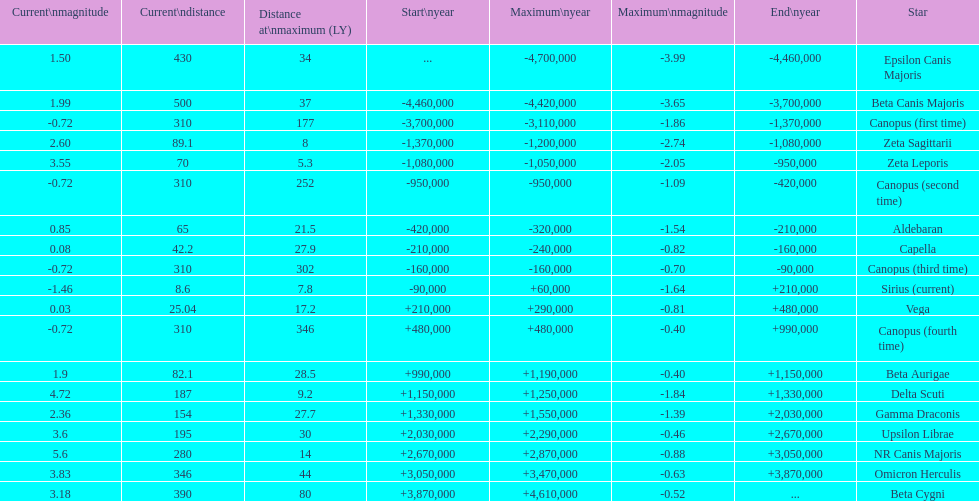I'm looking to parse the entire table for insights. Could you assist me with that? {'header': ['Current\\nmagnitude', 'Current\\ndistance', 'Distance at\\nmaximum (LY)', 'Start\\nyear', 'Maximum\\nyear', 'Maximum\\nmagnitude', 'End\\nyear', 'Star'], 'rows': [['1.50', '430', '34', '...', '-4,700,000', '-3.99', '-4,460,000', 'Epsilon Canis Majoris'], ['1.99', '500', '37', '-4,460,000', '-4,420,000', '-3.65', '-3,700,000', 'Beta Canis Majoris'], ['-0.72', '310', '177', '-3,700,000', '-3,110,000', '-1.86', '-1,370,000', 'Canopus (first time)'], ['2.60', '89.1', '8', '-1,370,000', '-1,200,000', '-2.74', '-1,080,000', 'Zeta Sagittarii'], ['3.55', '70', '5.3', '-1,080,000', '-1,050,000', '-2.05', '-950,000', 'Zeta Leporis'], ['-0.72', '310', '252', '-950,000', '-950,000', '-1.09', '-420,000', 'Canopus (second time)'], ['0.85', '65', '21.5', '-420,000', '-320,000', '-1.54', '-210,000', 'Aldebaran'], ['0.08', '42.2', '27.9', '-210,000', '-240,000', '-0.82', '-160,000', 'Capella'], ['-0.72', '310', '302', '-160,000', '-160,000', '-0.70', '-90,000', 'Canopus (third time)'], ['-1.46', '8.6', '7.8', '-90,000', '+60,000', '-1.64', '+210,000', 'Sirius (current)'], ['0.03', '25.04', '17.2', '+210,000', '+290,000', '-0.81', '+480,000', 'Vega'], ['-0.72', '310', '346', '+480,000', '+480,000', '-0.40', '+990,000', 'Canopus (fourth time)'], ['1.9', '82.1', '28.5', '+990,000', '+1,190,000', '-0.40', '+1,150,000', 'Beta Aurigae'], ['4.72', '187', '9.2', '+1,150,000', '+1,250,000', '-1.84', '+1,330,000', 'Delta Scuti'], ['2.36', '154', '27.7', '+1,330,000', '+1,550,000', '-1.39', '+2,030,000', 'Gamma Draconis'], ['3.6', '195', '30', '+2,030,000', '+2,290,000', '-0.46', '+2,670,000', 'Upsilon Librae'], ['5.6', '280', '14', '+2,670,000', '+2,870,000', '-0.88', '+3,050,000', 'NR Canis Majoris'], ['3.83', '346', '44', '+3,050,000', '+3,470,000', '-0.63', '+3,870,000', 'Omicron Herculis'], ['3.18', '390', '80', '+3,870,000', '+4,610,000', '-0.52', '...', 'Beta Cygni']]} How many stars have a current magnitude of at least 1.0? 11. 